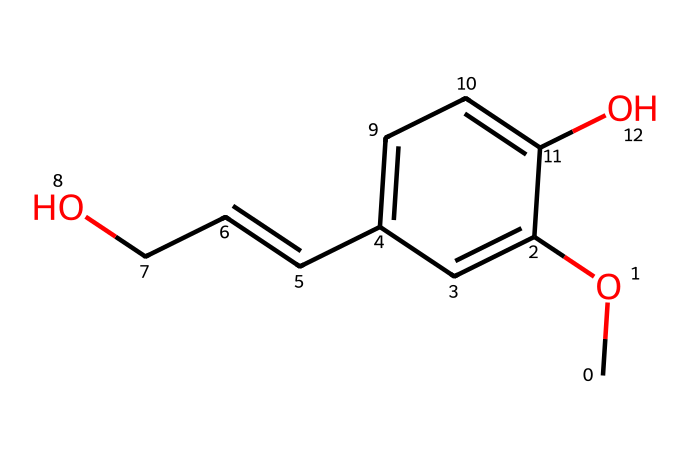What is the total number of carbon atoms in this chemical? By examining the SMILES representation, we can count the carbon atoms (C). The structure has a total of seven carbon atoms present.
Answer: seven How many oxygen atoms are in this molecule? From the SMILES structure, we can identify the oxygen atoms (O) which are present in two instances. Therefore, there are two oxygen atoms.
Answer: two What functional groups are present in this chemical? The SMILES shows a methoxy group (–OCH3) and a hydroxyl group (–OH) attached to the aromatic ring, indicating these functional groups are present.
Answer: methoxy and hydroxyl Is this compound more likely to be polar or non-polar? The presence of multiple hydroxyl groups and the polar ether (methoxy) suggests that this compound has a significant degree of polarity.
Answer: polar Which part of this chemical structure is responsible for its contaminant properties? The presence of hydroxyl groups can lead to strong hydrogen bonding and can negatively affect the structure and properties of the paper, making it a contaminant in aged materials.
Answer: hydroxyl groups What type of chemical compound is this? Given its structure, which has aromatic rings and functional groups such as ether and alcohol, this compound is classified as a phenolic compound.
Answer: phenolic compound 